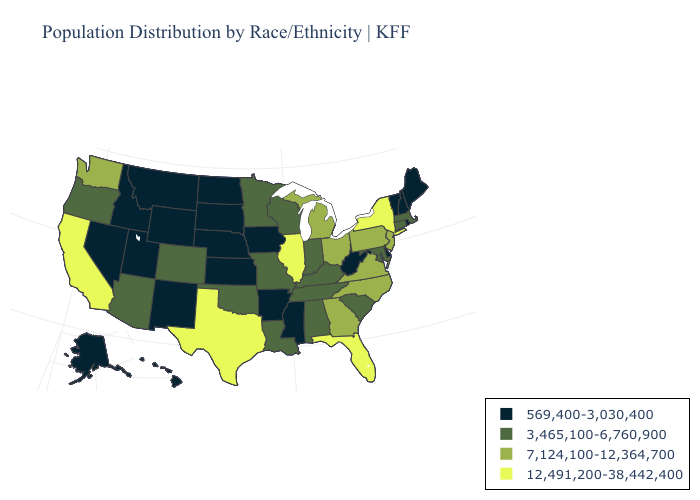Name the states that have a value in the range 569,400-3,030,400?
Keep it brief. Alaska, Arkansas, Delaware, Hawaii, Idaho, Iowa, Kansas, Maine, Mississippi, Montana, Nebraska, Nevada, New Hampshire, New Mexico, North Dakota, Rhode Island, South Dakota, Utah, Vermont, West Virginia, Wyoming. Does the first symbol in the legend represent the smallest category?
Keep it brief. Yes. What is the lowest value in states that border Minnesota?
Keep it brief. 569,400-3,030,400. Name the states that have a value in the range 7,124,100-12,364,700?
Write a very short answer. Georgia, Michigan, New Jersey, North Carolina, Ohio, Pennsylvania, Virginia, Washington. Name the states that have a value in the range 569,400-3,030,400?
Quick response, please. Alaska, Arkansas, Delaware, Hawaii, Idaho, Iowa, Kansas, Maine, Mississippi, Montana, Nebraska, Nevada, New Hampshire, New Mexico, North Dakota, Rhode Island, South Dakota, Utah, Vermont, West Virginia, Wyoming. What is the value of Illinois?
Write a very short answer. 12,491,200-38,442,400. Does Indiana have a lower value than North Dakota?
Answer briefly. No. What is the value of Arkansas?
Be succinct. 569,400-3,030,400. What is the value of Tennessee?
Be succinct. 3,465,100-6,760,900. Which states have the highest value in the USA?
Short answer required. California, Florida, Illinois, New York, Texas. What is the lowest value in the USA?
Be succinct. 569,400-3,030,400. Does Rhode Island have the lowest value in the Northeast?
Keep it brief. Yes. Does New York have the highest value in the Northeast?
Write a very short answer. Yes. What is the value of Nevada?
Short answer required. 569,400-3,030,400. Does the map have missing data?
Answer briefly. No. 